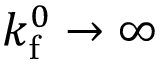<formula> <loc_0><loc_0><loc_500><loc_500>k _ { f } ^ { 0 } \rightarrow \infty</formula> 